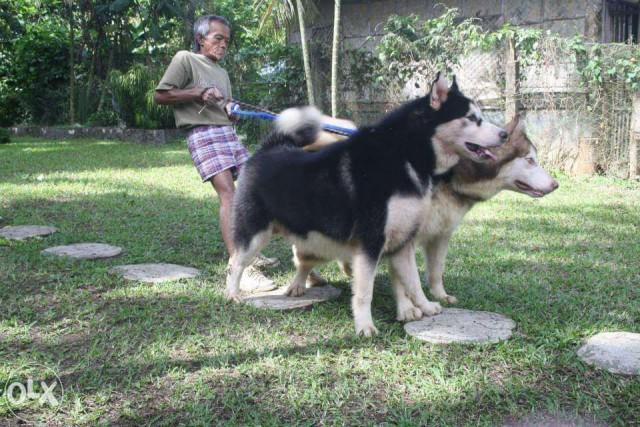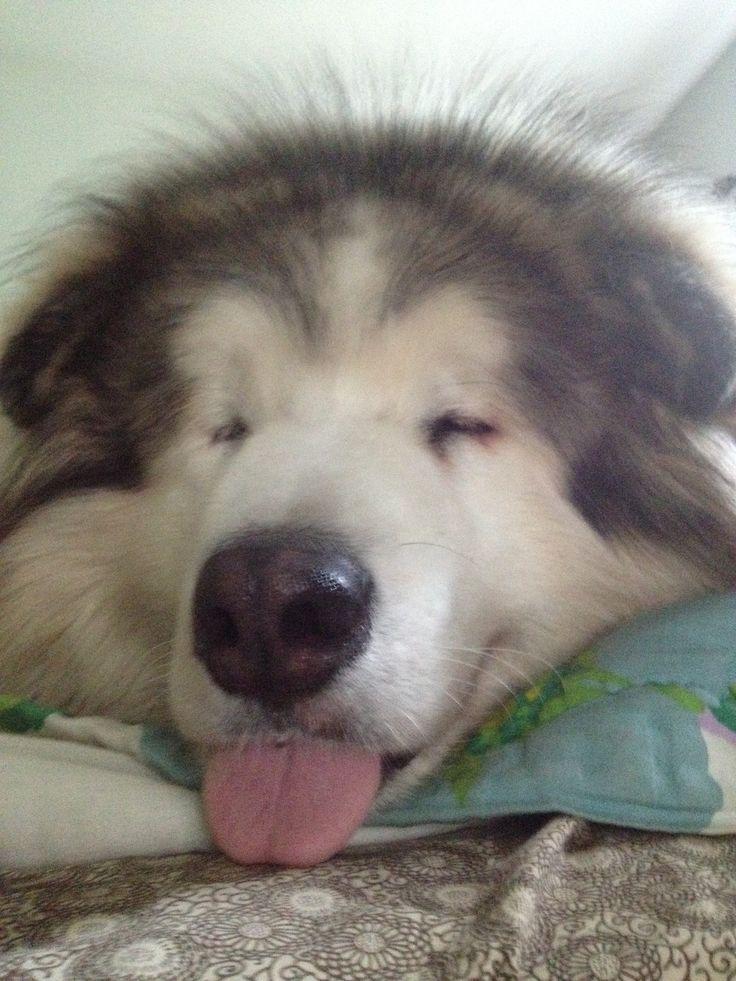The first image is the image on the left, the second image is the image on the right. Examine the images to the left and right. Is the description "There are an equal number of dogs in each image." accurate? Answer yes or no. No. The first image is the image on the left, the second image is the image on the right. Examine the images to the left and right. Is the description "The left and right image contains the same number of dogs." accurate? Answer yes or no. No. 